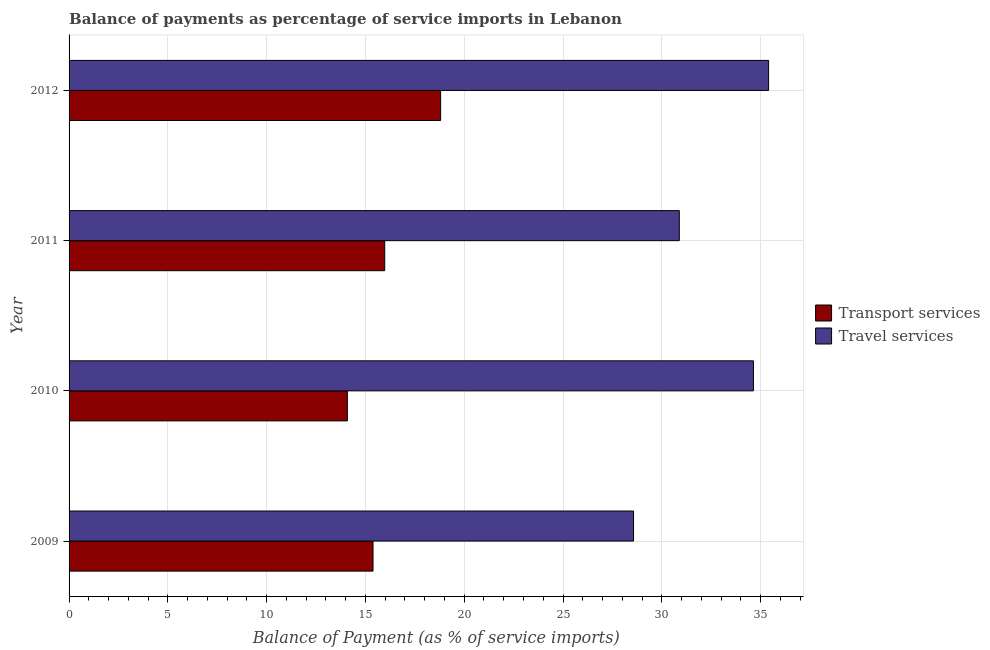How many different coloured bars are there?
Make the answer very short. 2. How many groups of bars are there?
Make the answer very short. 4. Are the number of bars per tick equal to the number of legend labels?
Your response must be concise. Yes. Are the number of bars on each tick of the Y-axis equal?
Offer a very short reply. Yes. How many bars are there on the 4th tick from the top?
Give a very brief answer. 2. How many bars are there on the 2nd tick from the bottom?
Offer a terse response. 2. What is the label of the 3rd group of bars from the top?
Provide a succinct answer. 2010. In how many cases, is the number of bars for a given year not equal to the number of legend labels?
Provide a short and direct response. 0. What is the balance of payments of travel services in 2012?
Your response must be concise. 35.4. Across all years, what is the maximum balance of payments of travel services?
Your answer should be compact. 35.4. Across all years, what is the minimum balance of payments of transport services?
Offer a very short reply. 14.08. In which year was the balance of payments of transport services maximum?
Your response must be concise. 2012. What is the total balance of payments of transport services in the graph?
Provide a succinct answer. 64.25. What is the difference between the balance of payments of transport services in 2010 and that in 2012?
Give a very brief answer. -4.72. What is the difference between the balance of payments of transport services in 2011 and the balance of payments of travel services in 2012?
Ensure brevity in your answer.  -19.43. What is the average balance of payments of travel services per year?
Your answer should be compact. 32.37. In the year 2012, what is the difference between the balance of payments of travel services and balance of payments of transport services?
Your answer should be compact. 16.6. In how many years, is the balance of payments of transport services greater than 18 %?
Ensure brevity in your answer.  1. What is the ratio of the balance of payments of transport services in 2009 to that in 2012?
Your answer should be very brief. 0.82. Is the difference between the balance of payments of transport services in 2009 and 2011 greater than the difference between the balance of payments of travel services in 2009 and 2011?
Provide a succinct answer. Yes. What is the difference between the highest and the second highest balance of payments of travel services?
Give a very brief answer. 0.77. What is the difference between the highest and the lowest balance of payments of transport services?
Your answer should be very brief. 4.72. Is the sum of the balance of payments of travel services in 2011 and 2012 greater than the maximum balance of payments of transport services across all years?
Your answer should be very brief. Yes. What does the 2nd bar from the top in 2009 represents?
Your response must be concise. Transport services. What does the 1st bar from the bottom in 2009 represents?
Offer a very short reply. Transport services. What is the title of the graph?
Keep it short and to the point. Balance of payments as percentage of service imports in Lebanon. Does "Urban" appear as one of the legend labels in the graph?
Ensure brevity in your answer.  No. What is the label or title of the X-axis?
Your response must be concise. Balance of Payment (as % of service imports). What is the label or title of the Y-axis?
Your answer should be compact. Year. What is the Balance of Payment (as % of service imports) of Transport services in 2009?
Make the answer very short. 15.38. What is the Balance of Payment (as % of service imports) of Travel services in 2009?
Offer a terse response. 28.57. What is the Balance of Payment (as % of service imports) in Transport services in 2010?
Make the answer very short. 14.08. What is the Balance of Payment (as % of service imports) in Travel services in 2010?
Keep it short and to the point. 34.64. What is the Balance of Payment (as % of service imports) in Transport services in 2011?
Provide a succinct answer. 15.98. What is the Balance of Payment (as % of service imports) of Travel services in 2011?
Give a very brief answer. 30.89. What is the Balance of Payment (as % of service imports) of Transport services in 2012?
Offer a very short reply. 18.81. What is the Balance of Payment (as % of service imports) in Travel services in 2012?
Your answer should be very brief. 35.4. Across all years, what is the maximum Balance of Payment (as % of service imports) of Transport services?
Offer a very short reply. 18.81. Across all years, what is the maximum Balance of Payment (as % of service imports) in Travel services?
Your answer should be very brief. 35.4. Across all years, what is the minimum Balance of Payment (as % of service imports) of Transport services?
Provide a short and direct response. 14.08. Across all years, what is the minimum Balance of Payment (as % of service imports) in Travel services?
Provide a succinct answer. 28.57. What is the total Balance of Payment (as % of service imports) in Transport services in the graph?
Keep it short and to the point. 64.25. What is the total Balance of Payment (as % of service imports) of Travel services in the graph?
Provide a succinct answer. 129.5. What is the difference between the Balance of Payment (as % of service imports) of Transport services in 2009 and that in 2010?
Give a very brief answer. 1.3. What is the difference between the Balance of Payment (as % of service imports) in Travel services in 2009 and that in 2010?
Provide a short and direct response. -6.07. What is the difference between the Balance of Payment (as % of service imports) of Transport services in 2009 and that in 2011?
Offer a terse response. -0.59. What is the difference between the Balance of Payment (as % of service imports) in Travel services in 2009 and that in 2011?
Offer a very short reply. -2.32. What is the difference between the Balance of Payment (as % of service imports) in Transport services in 2009 and that in 2012?
Your response must be concise. -3.42. What is the difference between the Balance of Payment (as % of service imports) in Travel services in 2009 and that in 2012?
Ensure brevity in your answer.  -6.83. What is the difference between the Balance of Payment (as % of service imports) of Transport services in 2010 and that in 2011?
Make the answer very short. -1.89. What is the difference between the Balance of Payment (as % of service imports) of Travel services in 2010 and that in 2011?
Make the answer very short. 3.75. What is the difference between the Balance of Payment (as % of service imports) of Transport services in 2010 and that in 2012?
Your answer should be very brief. -4.72. What is the difference between the Balance of Payment (as % of service imports) in Travel services in 2010 and that in 2012?
Your response must be concise. -0.77. What is the difference between the Balance of Payment (as % of service imports) of Transport services in 2011 and that in 2012?
Provide a short and direct response. -2.83. What is the difference between the Balance of Payment (as % of service imports) in Travel services in 2011 and that in 2012?
Ensure brevity in your answer.  -4.52. What is the difference between the Balance of Payment (as % of service imports) in Transport services in 2009 and the Balance of Payment (as % of service imports) in Travel services in 2010?
Ensure brevity in your answer.  -19.25. What is the difference between the Balance of Payment (as % of service imports) of Transport services in 2009 and the Balance of Payment (as % of service imports) of Travel services in 2011?
Give a very brief answer. -15.5. What is the difference between the Balance of Payment (as % of service imports) in Transport services in 2009 and the Balance of Payment (as % of service imports) in Travel services in 2012?
Provide a short and direct response. -20.02. What is the difference between the Balance of Payment (as % of service imports) of Transport services in 2010 and the Balance of Payment (as % of service imports) of Travel services in 2011?
Offer a terse response. -16.8. What is the difference between the Balance of Payment (as % of service imports) of Transport services in 2010 and the Balance of Payment (as % of service imports) of Travel services in 2012?
Give a very brief answer. -21.32. What is the difference between the Balance of Payment (as % of service imports) in Transport services in 2011 and the Balance of Payment (as % of service imports) in Travel services in 2012?
Offer a very short reply. -19.43. What is the average Balance of Payment (as % of service imports) of Transport services per year?
Your answer should be very brief. 16.06. What is the average Balance of Payment (as % of service imports) of Travel services per year?
Provide a succinct answer. 32.37. In the year 2009, what is the difference between the Balance of Payment (as % of service imports) of Transport services and Balance of Payment (as % of service imports) of Travel services?
Ensure brevity in your answer.  -13.19. In the year 2010, what is the difference between the Balance of Payment (as % of service imports) of Transport services and Balance of Payment (as % of service imports) of Travel services?
Your answer should be very brief. -20.55. In the year 2011, what is the difference between the Balance of Payment (as % of service imports) of Transport services and Balance of Payment (as % of service imports) of Travel services?
Keep it short and to the point. -14.91. In the year 2012, what is the difference between the Balance of Payment (as % of service imports) in Transport services and Balance of Payment (as % of service imports) in Travel services?
Your answer should be compact. -16.6. What is the ratio of the Balance of Payment (as % of service imports) of Transport services in 2009 to that in 2010?
Give a very brief answer. 1.09. What is the ratio of the Balance of Payment (as % of service imports) of Travel services in 2009 to that in 2010?
Your response must be concise. 0.82. What is the ratio of the Balance of Payment (as % of service imports) of Travel services in 2009 to that in 2011?
Offer a very short reply. 0.93. What is the ratio of the Balance of Payment (as % of service imports) of Transport services in 2009 to that in 2012?
Your response must be concise. 0.82. What is the ratio of the Balance of Payment (as % of service imports) of Travel services in 2009 to that in 2012?
Your answer should be very brief. 0.81. What is the ratio of the Balance of Payment (as % of service imports) of Transport services in 2010 to that in 2011?
Offer a terse response. 0.88. What is the ratio of the Balance of Payment (as % of service imports) of Travel services in 2010 to that in 2011?
Offer a very short reply. 1.12. What is the ratio of the Balance of Payment (as % of service imports) of Transport services in 2010 to that in 2012?
Ensure brevity in your answer.  0.75. What is the ratio of the Balance of Payment (as % of service imports) of Travel services in 2010 to that in 2012?
Provide a short and direct response. 0.98. What is the ratio of the Balance of Payment (as % of service imports) in Transport services in 2011 to that in 2012?
Keep it short and to the point. 0.85. What is the ratio of the Balance of Payment (as % of service imports) in Travel services in 2011 to that in 2012?
Make the answer very short. 0.87. What is the difference between the highest and the second highest Balance of Payment (as % of service imports) of Transport services?
Provide a short and direct response. 2.83. What is the difference between the highest and the second highest Balance of Payment (as % of service imports) in Travel services?
Your answer should be compact. 0.77. What is the difference between the highest and the lowest Balance of Payment (as % of service imports) of Transport services?
Your answer should be very brief. 4.72. What is the difference between the highest and the lowest Balance of Payment (as % of service imports) in Travel services?
Ensure brevity in your answer.  6.83. 